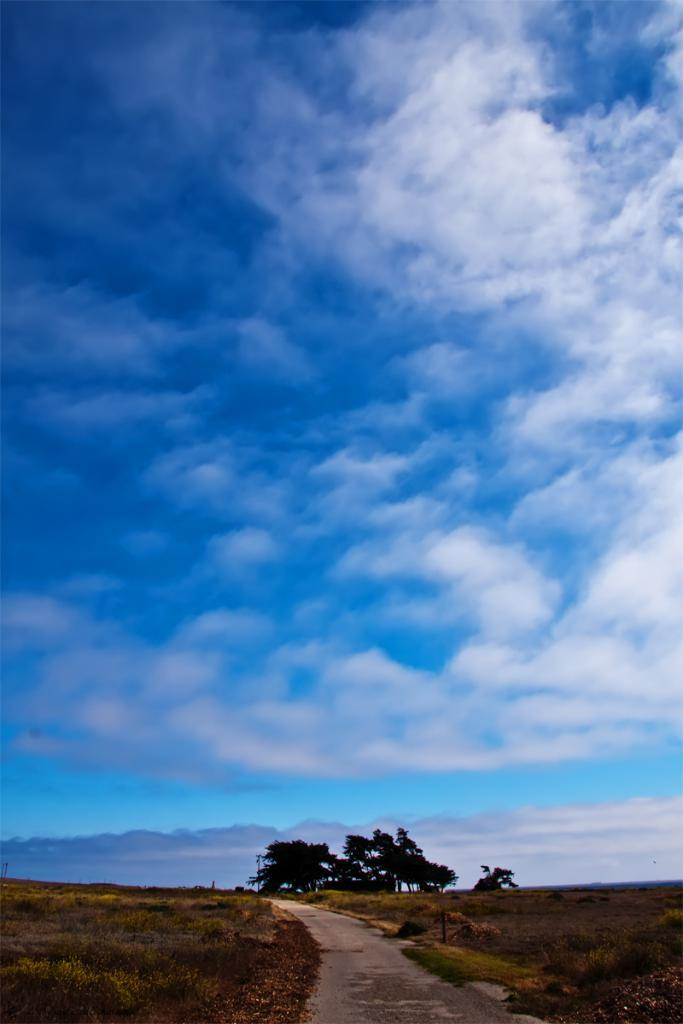What type of vegetation can be seen in the image? There are trees and plants in the image. What covers the ground in the image? The ground is covered with grass. What can be seen in the sky in the image? There are clouds in the sky. How many pigs are visible in the image? There are no pigs present in the image. What type of steel is used to construct the trees in the image? The trees in the image are natural, and there is no steel used in their construction. 